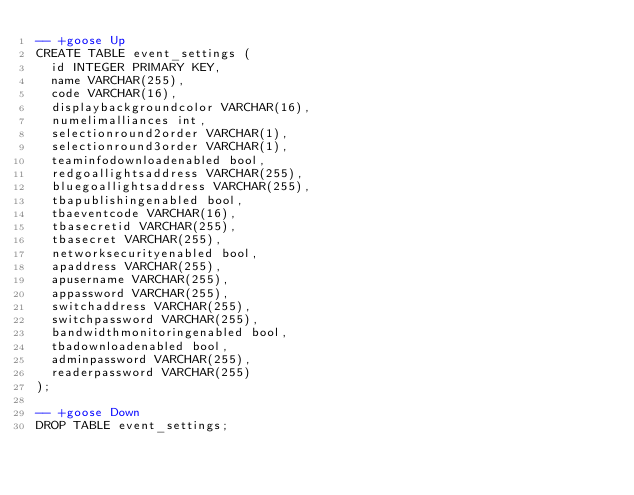<code> <loc_0><loc_0><loc_500><loc_500><_SQL_>-- +goose Up
CREATE TABLE event_settings (
  id INTEGER PRIMARY KEY,
  name VARCHAR(255),
  code VARCHAR(16),
  displaybackgroundcolor VARCHAR(16),
  numelimalliances int,
  selectionround2order VARCHAR(1),
  selectionround3order VARCHAR(1),
  teaminfodownloadenabled bool,
  redgoallightsaddress VARCHAR(255),
  bluegoallightsaddress VARCHAR(255),
  tbapublishingenabled bool,
  tbaeventcode VARCHAR(16),
  tbasecretid VARCHAR(255),
  tbasecret VARCHAR(255),
  networksecurityenabled bool,
  apaddress VARCHAR(255),
  apusername VARCHAR(255),
  appassword VARCHAR(255),
  switchaddress VARCHAR(255),
  switchpassword VARCHAR(255),
  bandwidthmonitoringenabled bool,
  tbadownloadenabled bool,
  adminpassword VARCHAR(255),
  readerpassword VARCHAR(255)
);

-- +goose Down
DROP TABLE event_settings;
</code> 